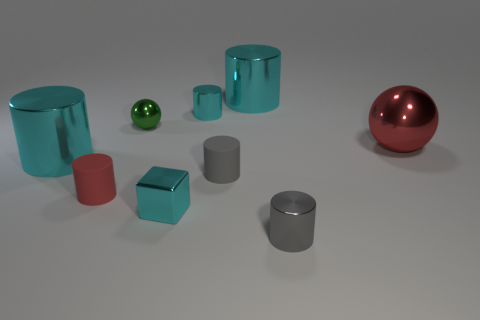What is the shape of the red matte object?
Your response must be concise. Cylinder. What number of objects are big cylinders to the left of the tiny red matte cylinder or big red objects?
Your answer should be very brief. 2. There is a red sphere that is made of the same material as the cyan cube; what is its size?
Keep it short and to the point. Large. Are there more small gray objects behind the tiny red cylinder than yellow metallic things?
Give a very brief answer. Yes. There is a small gray shiny thing; is its shape the same as the object that is behind the small cyan shiny cylinder?
Your response must be concise. Yes. What number of big things are green metal things or matte objects?
Your answer should be very brief. 0. There is a big metal cylinder behind the big object that is to the right of the small gray metal thing; what color is it?
Offer a very short reply. Cyan. Is the tiny red thing made of the same material as the cyan cylinder in front of the large red thing?
Give a very brief answer. No. There is a small cyan object that is in front of the tiny red matte cylinder; what is its material?
Ensure brevity in your answer.  Metal. Are there an equal number of big red spheres that are in front of the small gray matte cylinder and big gray metal things?
Keep it short and to the point. Yes. 